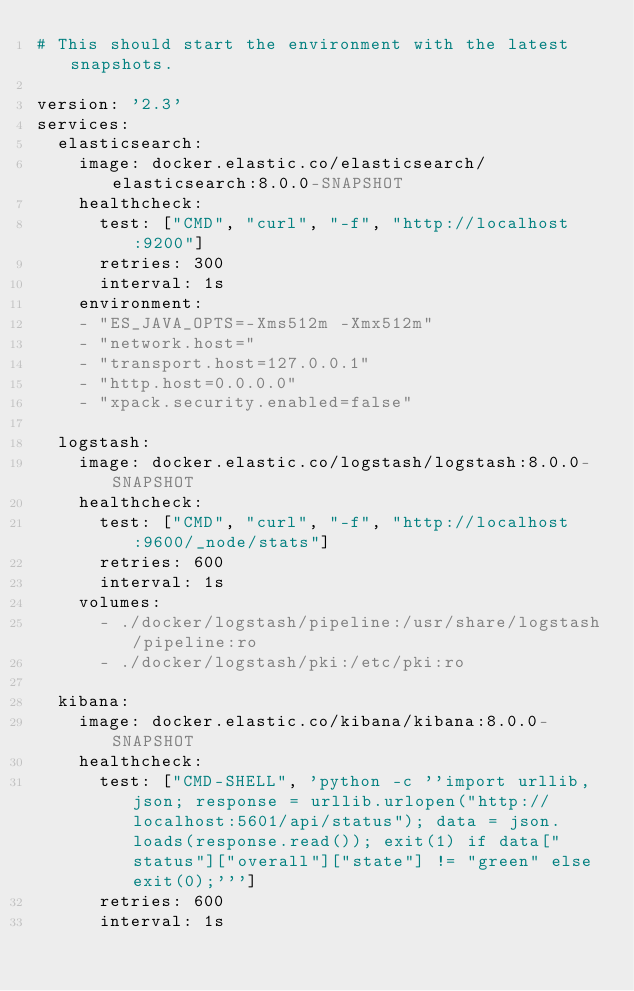<code> <loc_0><loc_0><loc_500><loc_500><_YAML_># This should start the environment with the latest snapshots.

version: '2.3'
services:
  elasticsearch:
    image: docker.elastic.co/elasticsearch/elasticsearch:8.0.0-SNAPSHOT
    healthcheck:
      test: ["CMD", "curl", "-f", "http://localhost:9200"]
      retries: 300
      interval: 1s
    environment:
    - "ES_JAVA_OPTS=-Xms512m -Xmx512m"
    - "network.host="
    - "transport.host=127.0.0.1"
    - "http.host=0.0.0.0"
    - "xpack.security.enabled=false"

  logstash:
    image: docker.elastic.co/logstash/logstash:8.0.0-SNAPSHOT
    healthcheck:
      test: ["CMD", "curl", "-f", "http://localhost:9600/_node/stats"]
      retries: 600
      interval: 1s
    volumes:
      - ./docker/logstash/pipeline:/usr/share/logstash/pipeline:ro
      - ./docker/logstash/pki:/etc/pki:ro

  kibana:
    image: docker.elastic.co/kibana/kibana:8.0.0-SNAPSHOT
    healthcheck:
      test: ["CMD-SHELL", 'python -c ''import urllib, json; response = urllib.urlopen("http://localhost:5601/api/status"); data = json.loads(response.read()); exit(1) if data["status"]["overall"]["state"] != "green" else exit(0);''']
      retries: 600
      interval: 1s
</code> 